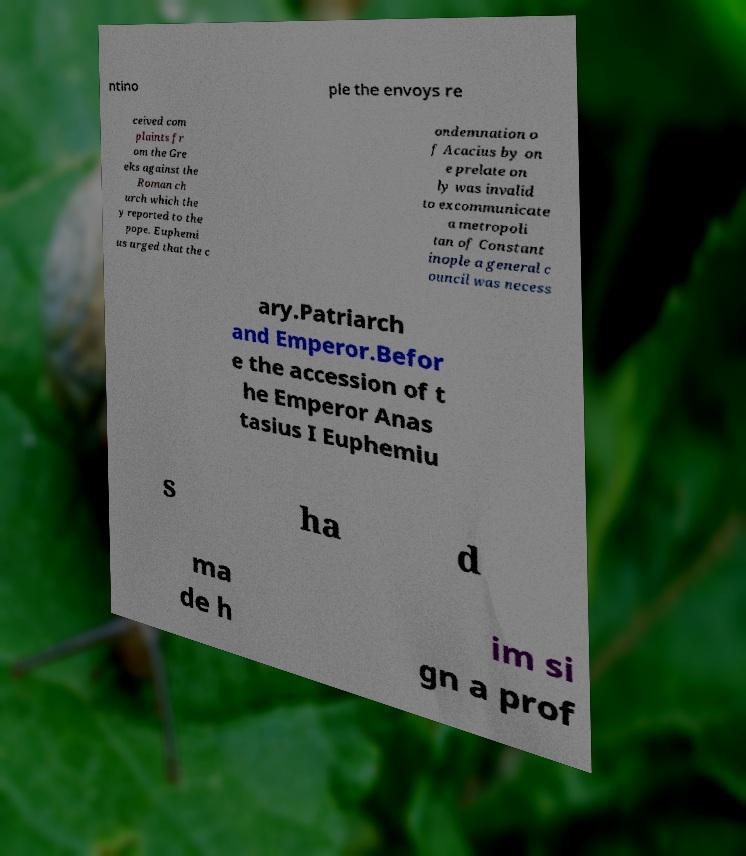For documentation purposes, I need the text within this image transcribed. Could you provide that? ntino ple the envoys re ceived com plaints fr om the Gre eks against the Roman ch urch which the y reported to the pope. Euphemi us urged that the c ondemnation o f Acacius by on e prelate on ly was invalid to excommunicate a metropoli tan of Constant inople a general c ouncil was necess ary.Patriarch and Emperor.Befor e the accession of t he Emperor Anas tasius I Euphemiu s ha d ma de h im si gn a prof 